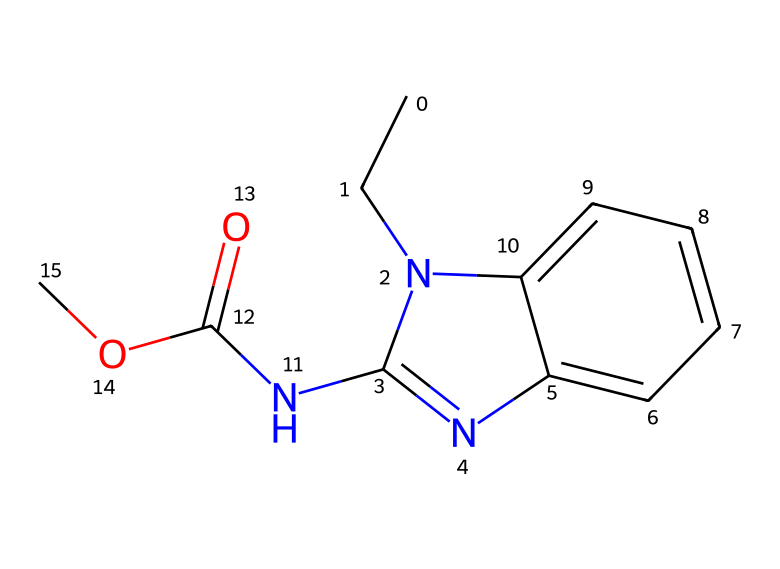What is the molecular formula of carbendazim? The SMILES representation provides information about the arrangement of atoms in the molecule. By analyzing the SMILES, we can count the different atoms: there are 12 carbon (C) atoms, 13 hydrogen (H) atoms, 4 nitrogen (N) atoms, and 3 oxygen (O) atoms, leading to the molecular formula C12H13N4O3.
Answer: C12H13N4O3 How many nitrogen atoms are in the structure of carbendazim? By examining the SMILES representation, we can identify the nitrogen atoms present. The notation 'n' indicates the presence of nitrogen in the rings in the structure. There are four occurrences of nitrogen in the formula, giving us a total of 4 nitrogen atoms.
Answer: 4 What functional group is present in carbendazim? The SMILES representation contains the notation 'NC(=O)OC', indicating the presence of an amide and ester functional group in the structure. The amide is identified by the nitrogen connected to a carbonyl (C=O), and the ester by the bond with an oxygen.
Answer: amide and ester Which part of the chemical indicates its antifungal properties? The arrangement of nitrogen atoms and the presence of conjugated systems (aromatic rings) in the structure contribute to the chemical's biological activity, including antifungal properties. Specifically, the presence of the benzene ring contributes to its effectiveness as a fungicide.
Answer: benzene ring Does carbendazim contain a ring structure? The presence of lowercase 'n' and the context of the SMILES notation indicate cyclic compounds. In the structure, there are two interconnected ring structures, which are typical for many fungicides, aiding in their stability and interaction with biological targets.
Answer: yes What is the significance of the ester group in fungicides like carbendazim? The ester group can enhance the solubility and permeability of the fungicide, playing a critical role in its effectiveness. In carbendazim, the ester connection (part of the amide) is involved in the mechanisms of action against fungal cells, making it critical for its fungicidal activity.
Answer: enhances solubility 